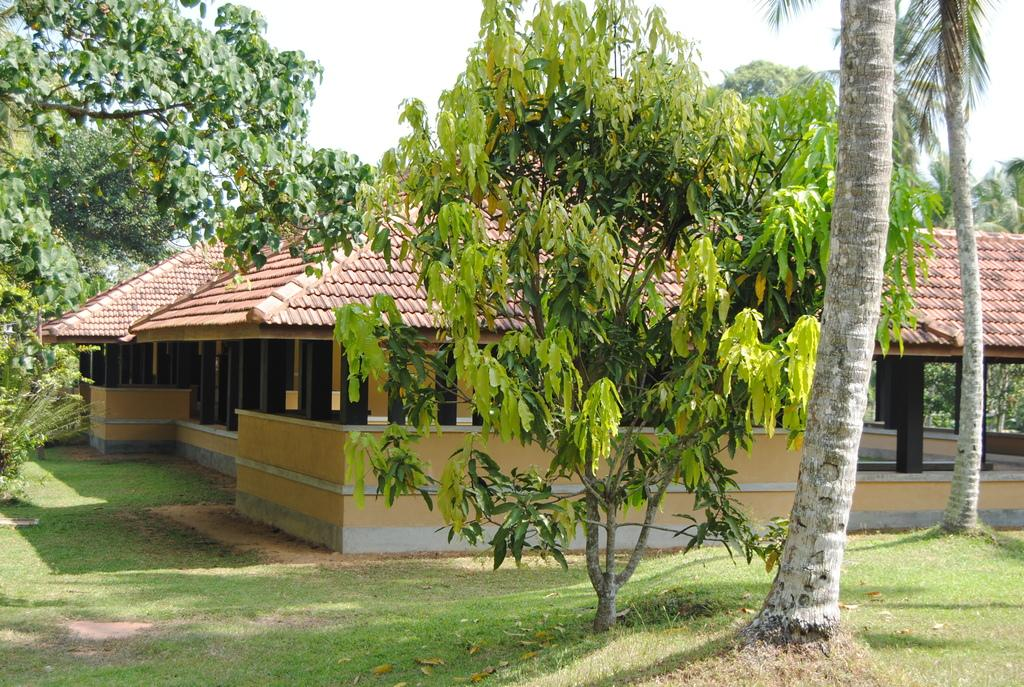What type of structure is present in the image? There is a shed in the image. What type of vegetation can be seen in the image? There are trees in the image. What is covering the ground in the image? There is grass on the ground in the image. What can be seen in the background of the image? The sky is visible in the background of the image. What type of polish is being applied to the trees in the image? There is no indication in the image that any polish is being applied to the trees; they appear to be natural. 